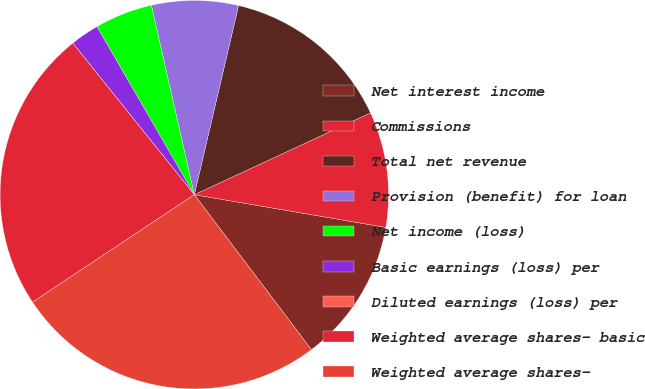Convert chart to OTSL. <chart><loc_0><loc_0><loc_500><loc_500><pie_chart><fcel>Net interest income<fcel>Commissions<fcel>Total net revenue<fcel>Provision (benefit) for loan<fcel>Net income (loss)<fcel>Basic earnings (loss) per<fcel>Diluted earnings (loss) per<fcel>Weighted average shares- basic<fcel>Weighted average shares-<nl><fcel>12.01%<fcel>9.61%<fcel>14.42%<fcel>7.21%<fcel>4.81%<fcel>2.4%<fcel>0.0%<fcel>23.57%<fcel>25.97%<nl></chart> 